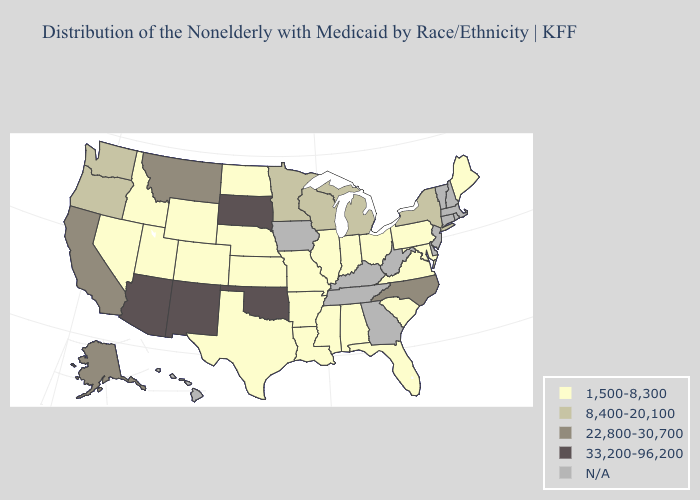Does the first symbol in the legend represent the smallest category?
Give a very brief answer. Yes. Does New York have the lowest value in the Northeast?
Give a very brief answer. No. What is the highest value in states that border Vermont?
Answer briefly. 8,400-20,100. What is the value of Wyoming?
Answer briefly. 1,500-8,300. Which states hav the highest value in the Northeast?
Give a very brief answer. New York. Does New York have the highest value in the Northeast?
Short answer required. Yes. Name the states that have a value in the range 33,200-96,200?
Concise answer only. Arizona, New Mexico, Oklahoma, South Dakota. Among the states that border North Carolina , which have the lowest value?
Answer briefly. South Carolina, Virginia. What is the value of Alabama?
Short answer required. 1,500-8,300. Does the map have missing data?
Quick response, please. Yes. What is the value of Delaware?
Give a very brief answer. N/A. What is the value of Louisiana?
Be succinct. 1,500-8,300. 